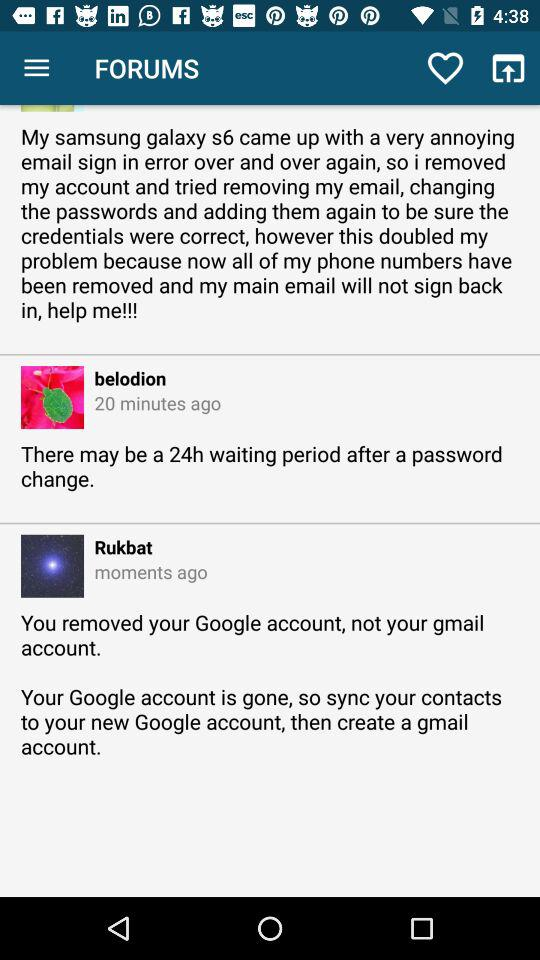How many more minutes ago did belodion post than Rukbat?
Answer the question using a single word or phrase. 20 